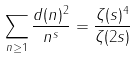Convert formula to latex. <formula><loc_0><loc_0><loc_500><loc_500>\sum _ { n \geq 1 } \frac { d ( n ) ^ { 2 } } { n ^ { s } } = \frac { \zeta ( s ) ^ { 4 } } { \zeta ( 2 s ) }</formula> 